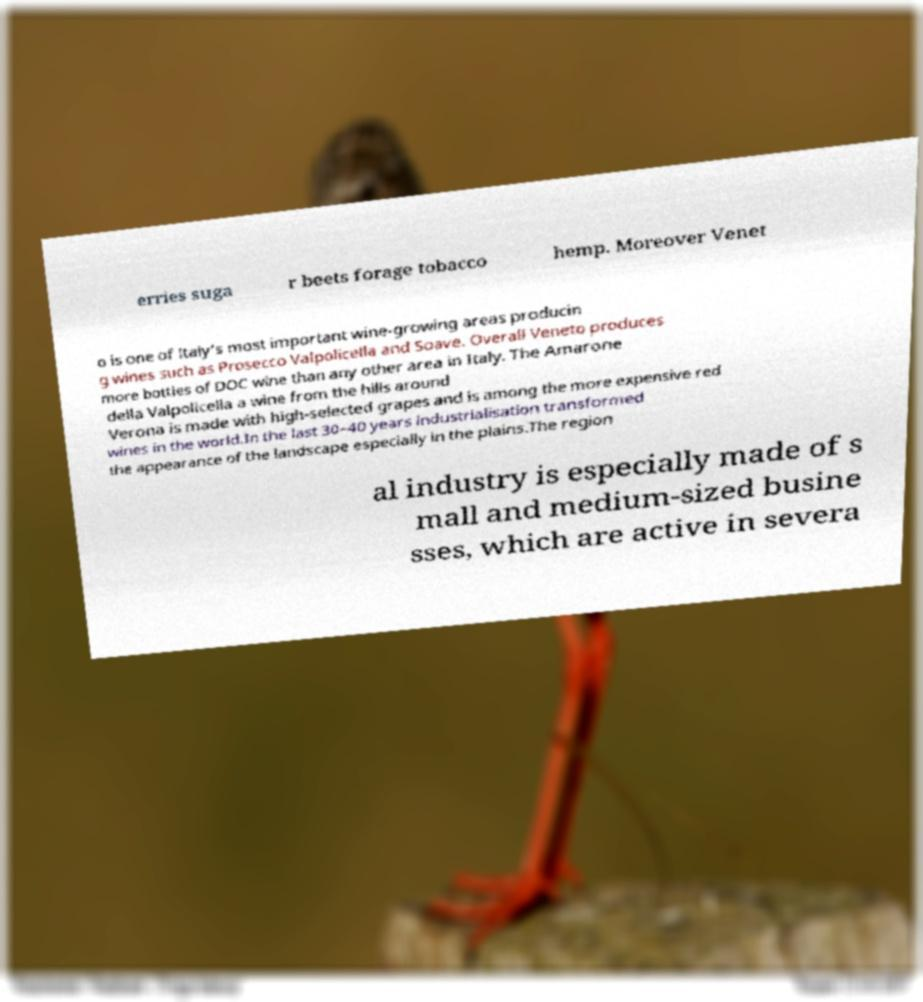Please identify and transcribe the text found in this image. erries suga r beets forage tobacco hemp. Moreover Venet o is one of Italy's most important wine-growing areas producin g wines such as Prosecco Valpolicella and Soave. Overall Veneto produces more bottles of DOC wine than any other area in Italy. The Amarone della Valpolicella a wine from the hills around Verona is made with high-selected grapes and is among the more expensive red wines in the world.In the last 30–40 years industrialisation transformed the appearance of the landscape especially in the plains.The region al industry is especially made of s mall and medium-sized busine sses, which are active in severa 